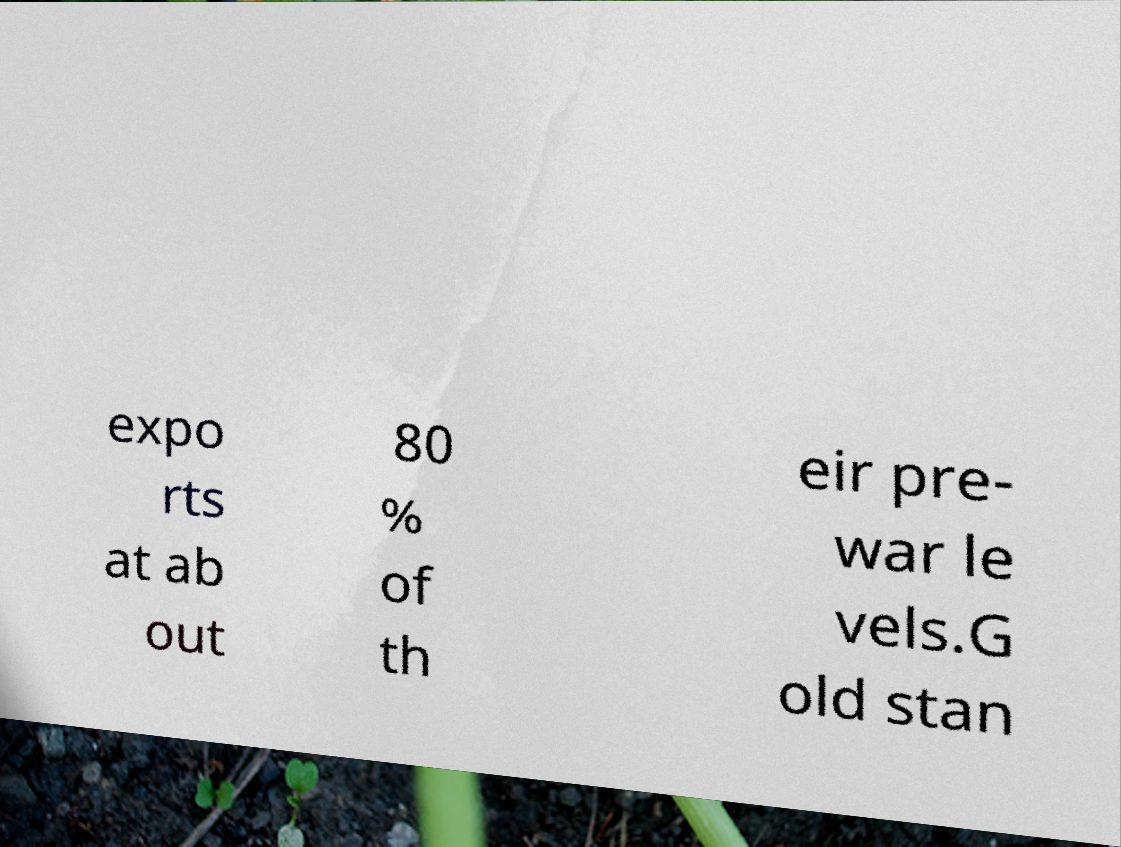Can you read and provide the text displayed in the image?This photo seems to have some interesting text. Can you extract and type it out for me? expo rts at ab out 80 % of th eir pre- war le vels.G old stan 